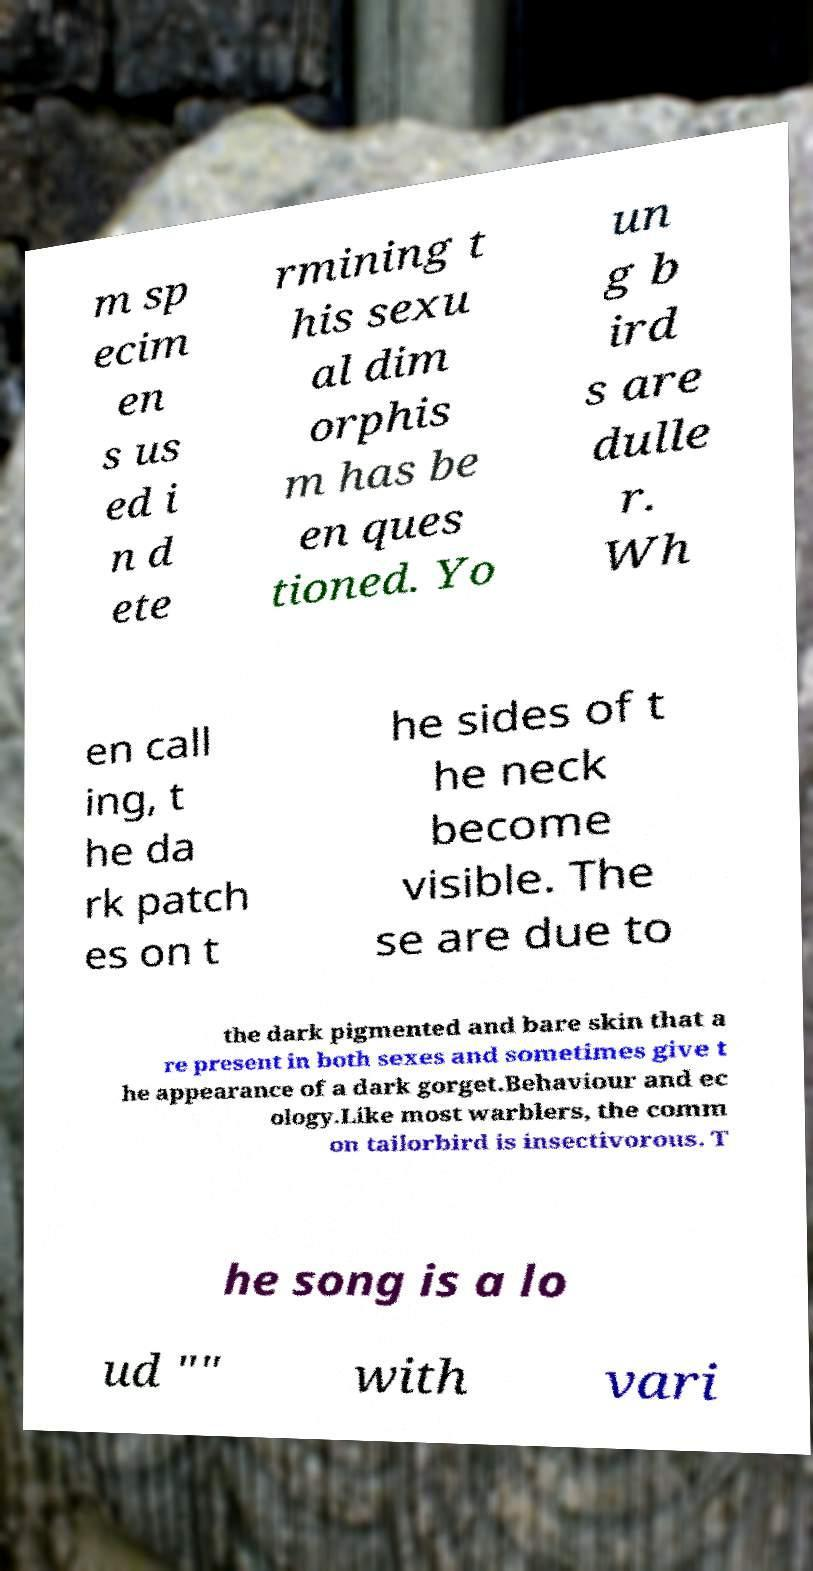Could you extract and type out the text from this image? m sp ecim en s us ed i n d ete rmining t his sexu al dim orphis m has be en ques tioned. Yo un g b ird s are dulle r. Wh en call ing, t he da rk patch es on t he sides of t he neck become visible. The se are due to the dark pigmented and bare skin that a re present in both sexes and sometimes give t he appearance of a dark gorget.Behaviour and ec ology.Like most warblers, the comm on tailorbird is insectivorous. T he song is a lo ud "" with vari 